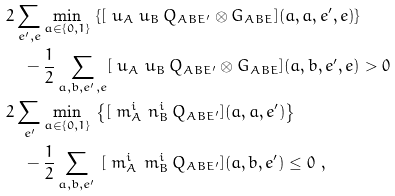<formula> <loc_0><loc_0><loc_500><loc_500>& 2 \sum _ { e ^ { \prime } , e } \min _ { a \in \{ 0 , 1 \} } \, \left \{ [ \ u _ { A } \ u _ { B } \, Q _ { A B E ^ { \prime } } \otimes G _ { A B E } ] ( a , a , e ^ { \prime } , e ) \right \} \\ & \quad - \frac { 1 } { 2 } \sum _ { a , b , e ^ { \prime } , e } [ \ u _ { A } \ u _ { B } \, Q _ { A B E ^ { \prime } } \otimes G _ { A B E } ] ( a , b , e ^ { \prime } , e ) > 0 \\ & 2 \sum _ { e ^ { \prime } } \min _ { a \in \{ 0 , 1 \} } \, \left \{ [ \ m ^ { i } _ { A } \ n ^ { i } _ { B } \, Q _ { A B E ^ { \prime } } ] ( a , a , e ^ { \prime } ) \right \} \\ & \quad - \frac { 1 } { 2 } \sum _ { a , b , e ^ { \prime } } \ [ \ m ^ { i } _ { A } \ m ^ { i } _ { B } \, Q _ { A B E ^ { \prime } } ] ( a , b , e ^ { \prime } ) \leq 0 \ ,</formula> 